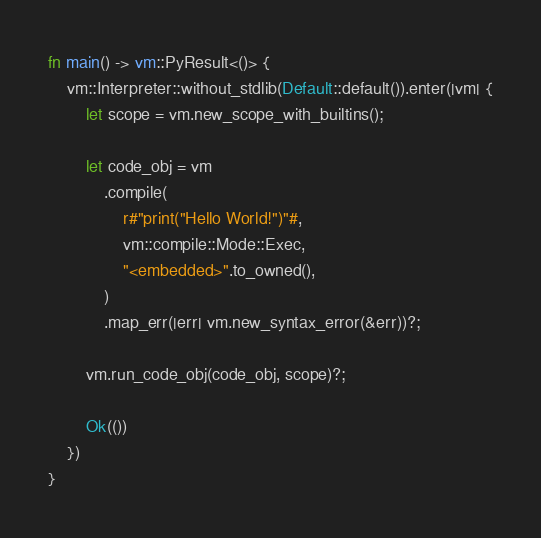Convert code to text. <code><loc_0><loc_0><loc_500><loc_500><_Rust_>
fn main() -> vm::PyResult<()> {
    vm::Interpreter::without_stdlib(Default::default()).enter(|vm| {
        let scope = vm.new_scope_with_builtins();

        let code_obj = vm
            .compile(
                r#"print("Hello World!")"#,
                vm::compile::Mode::Exec,
                "<embedded>".to_owned(),
            )
            .map_err(|err| vm.new_syntax_error(&err))?;

        vm.run_code_obj(code_obj, scope)?;

        Ok(())
    })
}
</code> 